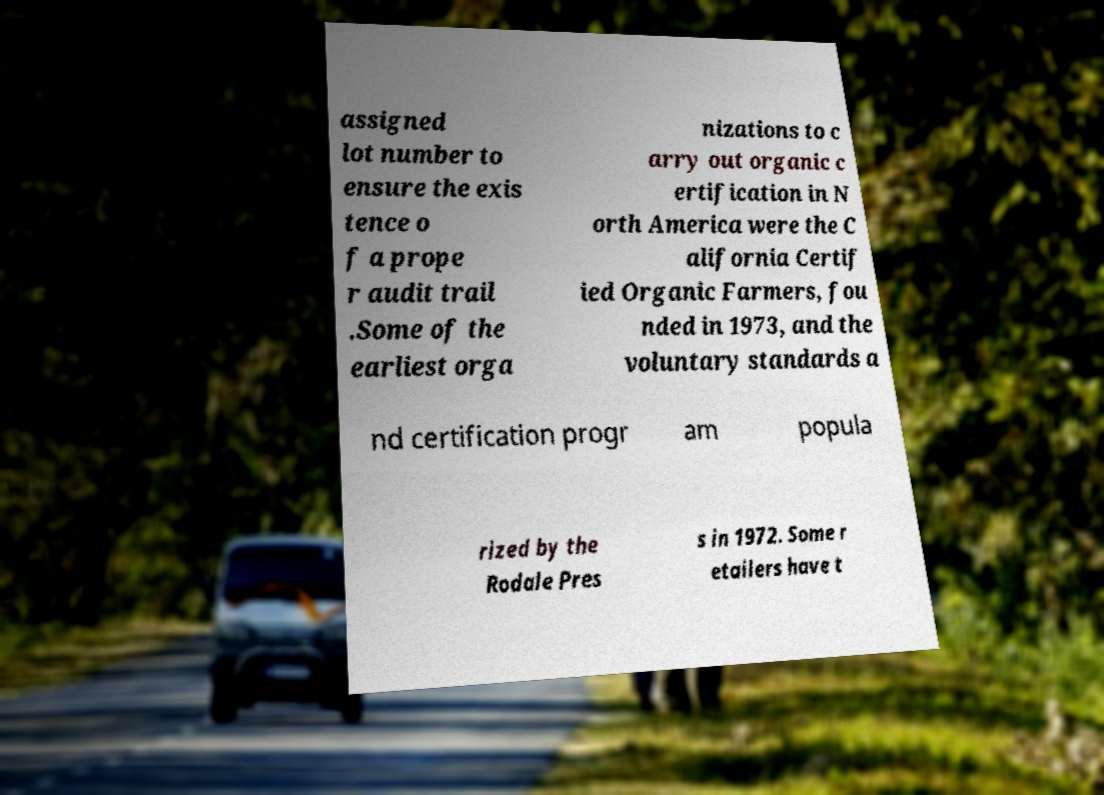For documentation purposes, I need the text within this image transcribed. Could you provide that? assigned lot number to ensure the exis tence o f a prope r audit trail .Some of the earliest orga nizations to c arry out organic c ertification in N orth America were the C alifornia Certif ied Organic Farmers, fou nded in 1973, and the voluntary standards a nd certification progr am popula rized by the Rodale Pres s in 1972. Some r etailers have t 